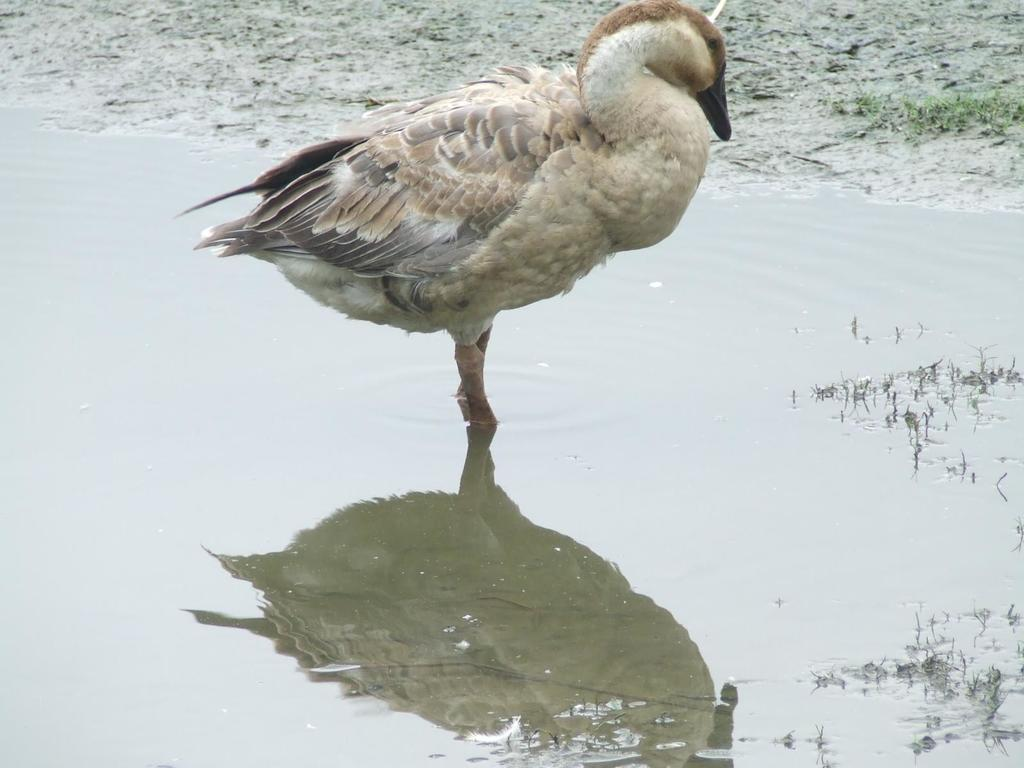What is the main subject of the image? There is a bird in the water in the image. Can you describe the bird's appearance? The bird has cream and brown colors. What can be seen in the background of the image? The grass in the background is green. What type of cup is the bird holding in its hand during the voyage in the image? There is no cup or hand present in the image, and the bird is not depicted as being on a voyage. 